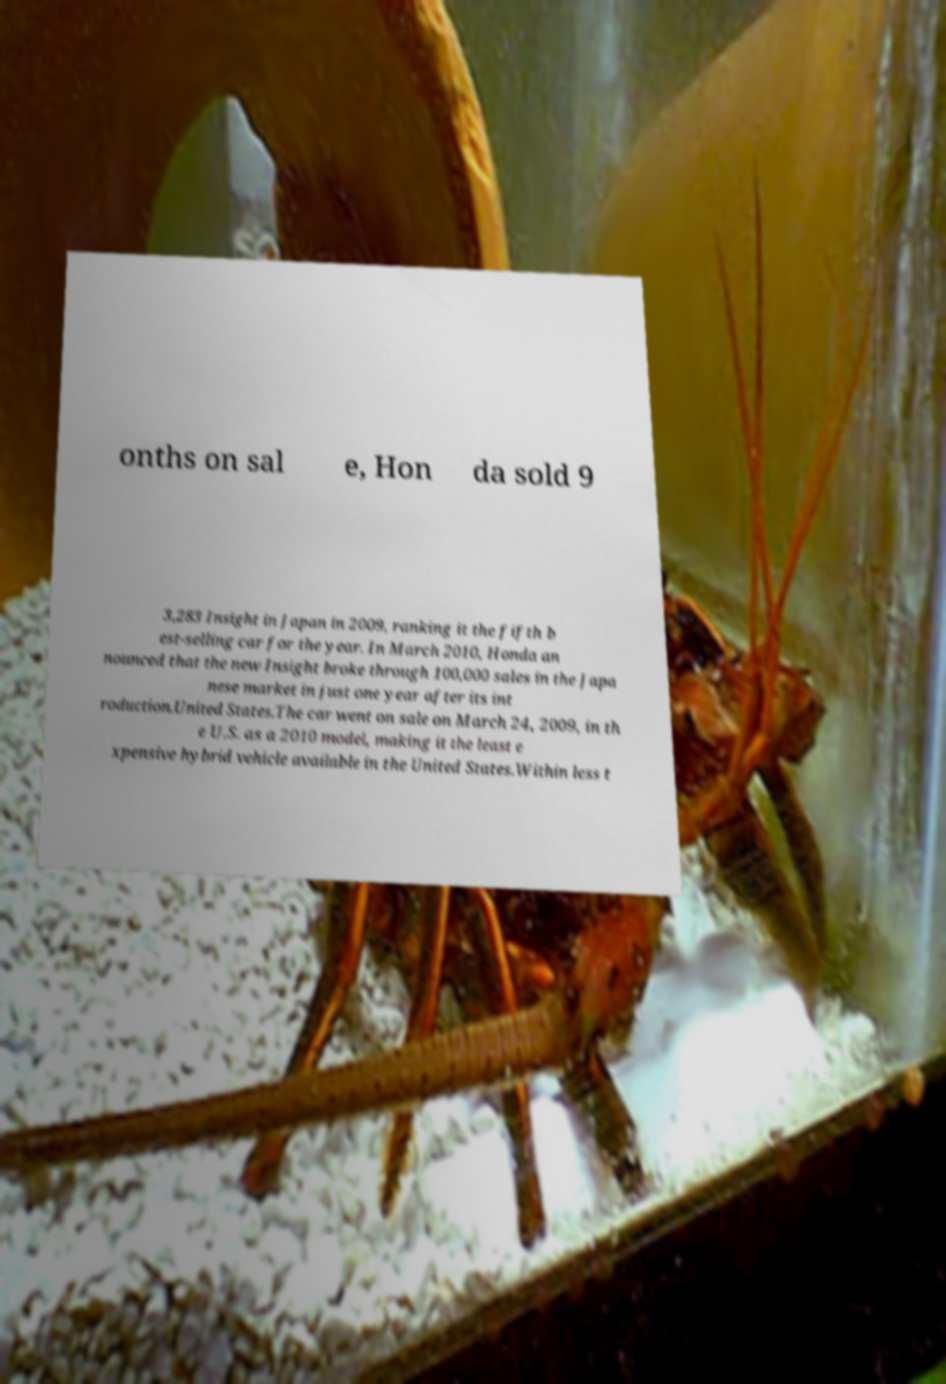Can you accurately transcribe the text from the provided image for me? onths on sal e, Hon da sold 9 3,283 Insight in Japan in 2009, ranking it the fifth b est-selling car for the year. In March 2010, Honda an nounced that the new Insight broke through 100,000 sales in the Japa nese market in just one year after its int roduction.United States.The car went on sale on March 24, 2009, in th e U.S. as a 2010 model, making it the least e xpensive hybrid vehicle available in the United States.Within less t 